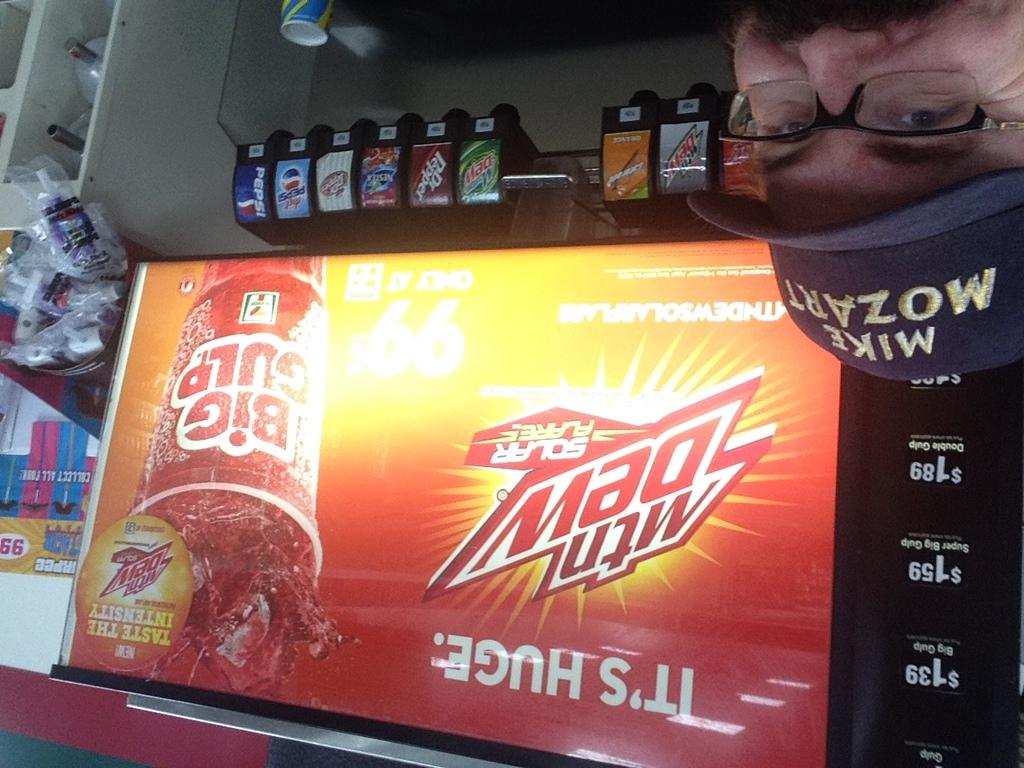<image>
Provide a brief description of the given image. A man wearing a MIke Mozart hat is standing in front of a big gulp machine. 